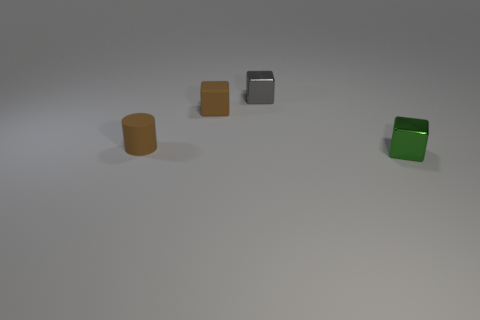Subtract all brown matte blocks. How many blocks are left? 2 Add 1 tiny shiny objects. How many objects exist? 5 Subtract all cylinders. How many objects are left? 3 Subtract all gray blocks. How many red cylinders are left? 0 Subtract all big gray matte things. Subtract all metal things. How many objects are left? 2 Add 1 small brown cylinders. How many small brown cylinders are left? 2 Add 3 tiny gray cubes. How many tiny gray cubes exist? 4 Subtract all brown cubes. How many cubes are left? 2 Subtract 0 purple balls. How many objects are left? 4 Subtract all green cubes. Subtract all purple spheres. How many cubes are left? 2 